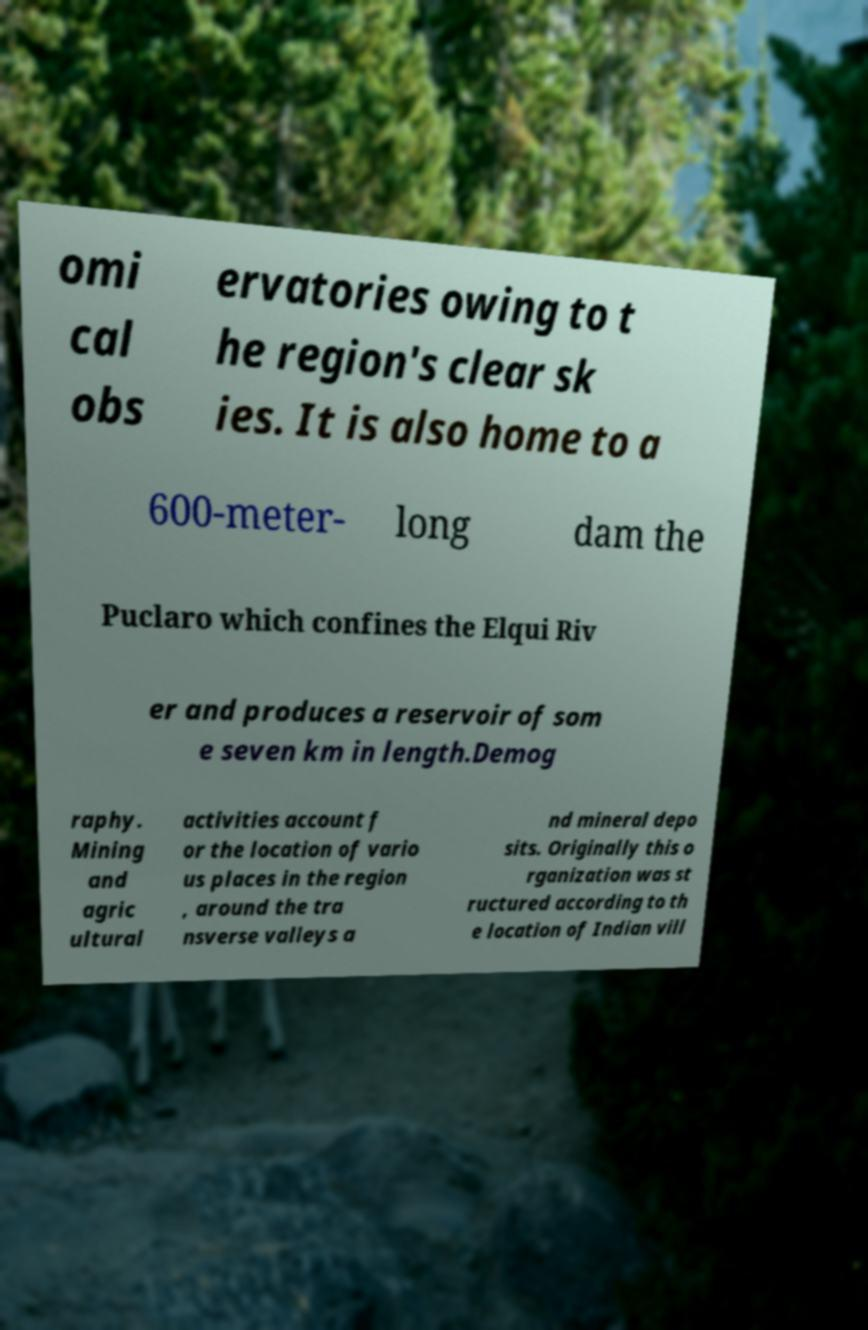Can you accurately transcribe the text from the provided image for me? omi cal obs ervatories owing to t he region's clear sk ies. It is also home to a 600-meter- long dam the Puclaro which confines the Elqui Riv er and produces a reservoir of som e seven km in length.Demog raphy. Mining and agric ultural activities account f or the location of vario us places in the region , around the tra nsverse valleys a nd mineral depo sits. Originally this o rganization was st ructured according to th e location of Indian vill 